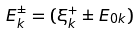Convert formula to latex. <formula><loc_0><loc_0><loc_500><loc_500>E _ { k } ^ { \pm } = ( \xi _ { k } ^ { + } \pm E _ { 0 { k } } )</formula> 